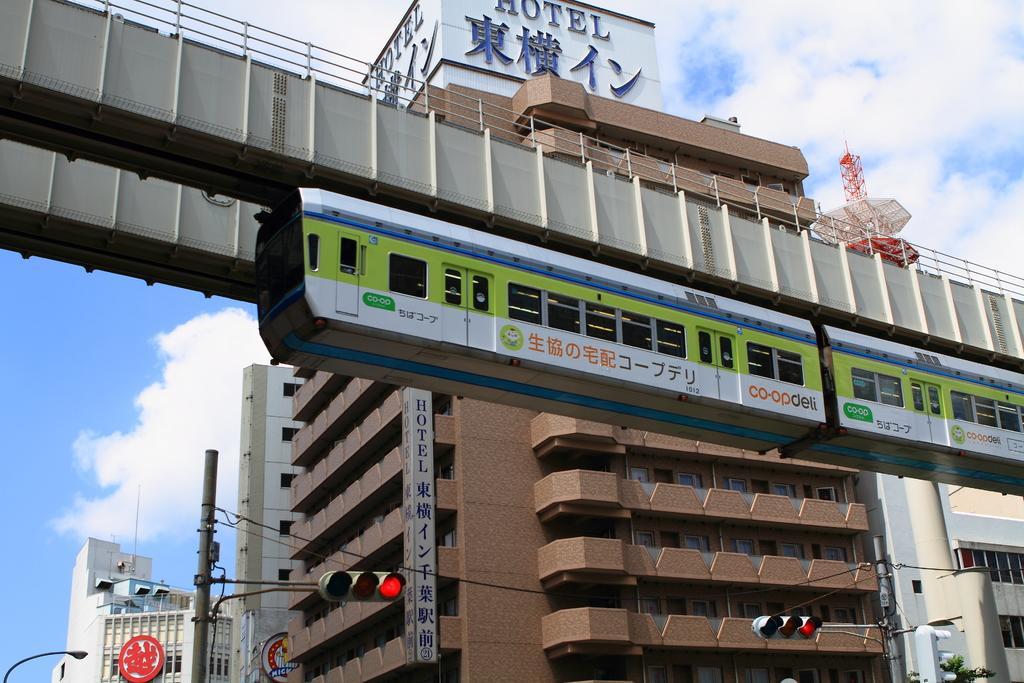Describe this image in one or two sentences. These are the buildings with the windows. I can see the traffic signals, which are attached to the poles. This is a train, which is on the rail track. I can see a name board, which is at the top of the building. This looks like a tower. These are the clouds in the sky. 